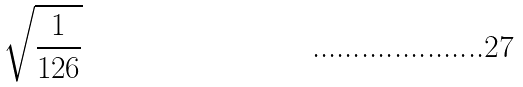Convert formula to latex. <formula><loc_0><loc_0><loc_500><loc_500>\sqrt { \frac { 1 } { 1 2 6 } }</formula> 